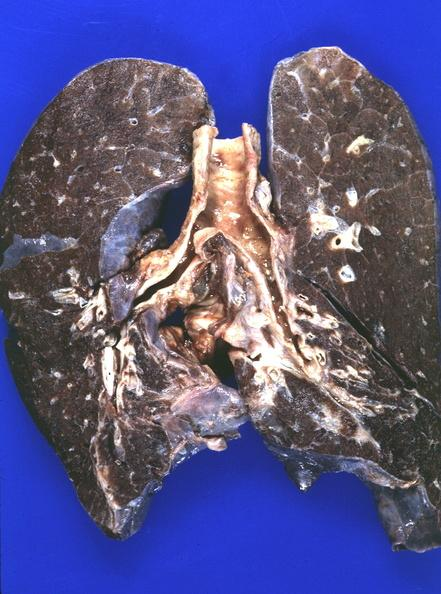where is this?
Answer the question using a single word or phrase. Lung 